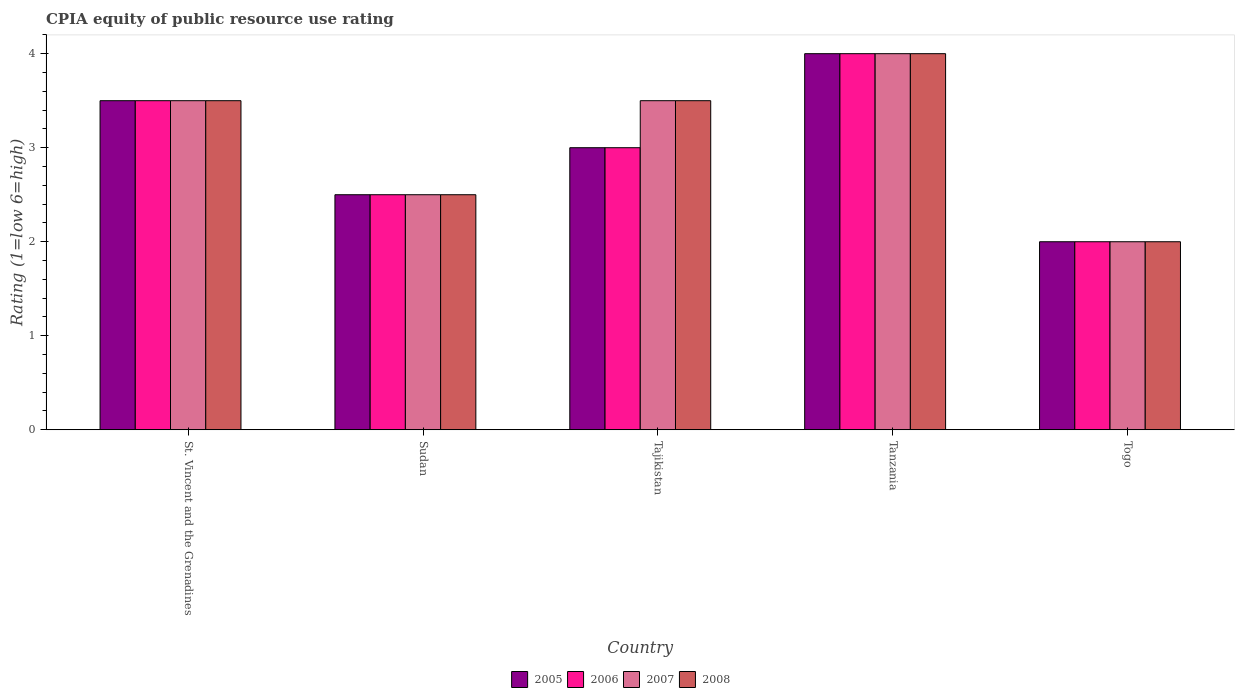Are the number of bars per tick equal to the number of legend labels?
Offer a terse response. Yes. Are the number of bars on each tick of the X-axis equal?
Your answer should be compact. Yes. What is the label of the 3rd group of bars from the left?
Your answer should be very brief. Tajikistan. In how many cases, is the number of bars for a given country not equal to the number of legend labels?
Ensure brevity in your answer.  0. Across all countries, what is the minimum CPIA rating in 2007?
Make the answer very short. 2. In which country was the CPIA rating in 2007 maximum?
Keep it short and to the point. Tanzania. In which country was the CPIA rating in 2007 minimum?
Provide a succinct answer. Togo. What is the difference between the CPIA rating in 2008 in St. Vincent and the Grenadines and that in Togo?
Keep it short and to the point. 1.5. What is the ratio of the CPIA rating in 2006 in Tajikistan to that in Tanzania?
Your answer should be very brief. 0.75. Is the CPIA rating in 2006 in St. Vincent and the Grenadines less than that in Togo?
Offer a very short reply. No. What is the difference between the highest and the lowest CPIA rating in 2006?
Give a very brief answer. 2. Is the sum of the CPIA rating in 2005 in Tanzania and Togo greater than the maximum CPIA rating in 2006 across all countries?
Offer a very short reply. Yes. Is it the case that in every country, the sum of the CPIA rating in 2006 and CPIA rating in 2008 is greater than the sum of CPIA rating in 2007 and CPIA rating in 2005?
Give a very brief answer. No. What does the 4th bar from the right in Tajikistan represents?
Keep it short and to the point. 2005. How many countries are there in the graph?
Your answer should be compact. 5. What is the difference between two consecutive major ticks on the Y-axis?
Your answer should be very brief. 1. Are the values on the major ticks of Y-axis written in scientific E-notation?
Make the answer very short. No. Does the graph contain any zero values?
Your answer should be very brief. No. Does the graph contain grids?
Give a very brief answer. No. Where does the legend appear in the graph?
Offer a very short reply. Bottom center. How are the legend labels stacked?
Offer a very short reply. Horizontal. What is the title of the graph?
Ensure brevity in your answer.  CPIA equity of public resource use rating. What is the Rating (1=low 6=high) of 2006 in St. Vincent and the Grenadines?
Offer a terse response. 3.5. What is the Rating (1=low 6=high) in 2007 in St. Vincent and the Grenadines?
Offer a terse response. 3.5. What is the Rating (1=low 6=high) of 2008 in St. Vincent and the Grenadines?
Keep it short and to the point. 3.5. What is the Rating (1=low 6=high) of 2006 in Sudan?
Make the answer very short. 2.5. What is the Rating (1=low 6=high) of 2007 in Sudan?
Offer a terse response. 2.5. What is the Rating (1=low 6=high) of 2005 in Tajikistan?
Ensure brevity in your answer.  3. What is the Rating (1=low 6=high) in 2007 in Tajikistan?
Make the answer very short. 3.5. What is the Rating (1=low 6=high) of 2005 in Tanzania?
Give a very brief answer. 4. What is the Rating (1=low 6=high) of 2006 in Tanzania?
Your answer should be compact. 4. What is the Rating (1=low 6=high) of 2007 in Togo?
Give a very brief answer. 2. What is the Rating (1=low 6=high) of 2008 in Togo?
Make the answer very short. 2. Across all countries, what is the minimum Rating (1=low 6=high) in 2006?
Give a very brief answer. 2. Across all countries, what is the minimum Rating (1=low 6=high) of 2008?
Give a very brief answer. 2. What is the total Rating (1=low 6=high) of 2005 in the graph?
Your answer should be compact. 15. What is the total Rating (1=low 6=high) in 2006 in the graph?
Your answer should be very brief. 15. What is the total Rating (1=low 6=high) of 2008 in the graph?
Your answer should be compact. 15.5. What is the difference between the Rating (1=low 6=high) of 2005 in St. Vincent and the Grenadines and that in Sudan?
Your response must be concise. 1. What is the difference between the Rating (1=low 6=high) in 2006 in St. Vincent and the Grenadines and that in Sudan?
Provide a succinct answer. 1. What is the difference between the Rating (1=low 6=high) in 2007 in St. Vincent and the Grenadines and that in Sudan?
Make the answer very short. 1. What is the difference between the Rating (1=low 6=high) of 2005 in St. Vincent and the Grenadines and that in Tajikistan?
Make the answer very short. 0.5. What is the difference between the Rating (1=low 6=high) in 2007 in St. Vincent and the Grenadines and that in Tajikistan?
Your answer should be compact. 0. What is the difference between the Rating (1=low 6=high) of 2006 in St. Vincent and the Grenadines and that in Tanzania?
Give a very brief answer. -0.5. What is the difference between the Rating (1=low 6=high) of 2007 in St. Vincent and the Grenadines and that in Tanzania?
Offer a very short reply. -0.5. What is the difference between the Rating (1=low 6=high) of 2006 in St. Vincent and the Grenadines and that in Togo?
Make the answer very short. 1.5. What is the difference between the Rating (1=low 6=high) in 2008 in St. Vincent and the Grenadines and that in Togo?
Keep it short and to the point. 1.5. What is the difference between the Rating (1=low 6=high) in 2005 in Sudan and that in Tajikistan?
Your answer should be very brief. -0.5. What is the difference between the Rating (1=low 6=high) in 2007 in Sudan and that in Tajikistan?
Provide a succinct answer. -1. What is the difference between the Rating (1=low 6=high) of 2008 in Sudan and that in Tajikistan?
Your response must be concise. -1. What is the difference between the Rating (1=low 6=high) of 2005 in Sudan and that in Tanzania?
Offer a very short reply. -1.5. What is the difference between the Rating (1=low 6=high) in 2007 in Sudan and that in Tanzania?
Keep it short and to the point. -1.5. What is the difference between the Rating (1=low 6=high) of 2008 in Sudan and that in Tanzania?
Your answer should be very brief. -1.5. What is the difference between the Rating (1=low 6=high) of 2006 in Sudan and that in Togo?
Provide a short and direct response. 0.5. What is the difference between the Rating (1=low 6=high) of 2007 in Sudan and that in Togo?
Ensure brevity in your answer.  0.5. What is the difference between the Rating (1=low 6=high) in 2006 in Tajikistan and that in Tanzania?
Your answer should be compact. -1. What is the difference between the Rating (1=low 6=high) of 2006 in Tajikistan and that in Togo?
Keep it short and to the point. 1. What is the difference between the Rating (1=low 6=high) of 2007 in Tajikistan and that in Togo?
Keep it short and to the point. 1.5. What is the difference between the Rating (1=low 6=high) in 2008 in Tajikistan and that in Togo?
Keep it short and to the point. 1.5. What is the difference between the Rating (1=low 6=high) in 2007 in Tanzania and that in Togo?
Ensure brevity in your answer.  2. What is the difference between the Rating (1=low 6=high) of 2008 in Tanzania and that in Togo?
Ensure brevity in your answer.  2. What is the difference between the Rating (1=low 6=high) in 2005 in St. Vincent and the Grenadines and the Rating (1=low 6=high) in 2007 in Sudan?
Your answer should be compact. 1. What is the difference between the Rating (1=low 6=high) in 2006 in St. Vincent and the Grenadines and the Rating (1=low 6=high) in 2007 in Sudan?
Offer a terse response. 1. What is the difference between the Rating (1=low 6=high) of 2005 in St. Vincent and the Grenadines and the Rating (1=low 6=high) of 2006 in Tajikistan?
Provide a succinct answer. 0.5. What is the difference between the Rating (1=low 6=high) of 2005 in St. Vincent and the Grenadines and the Rating (1=low 6=high) of 2007 in Tajikistan?
Keep it short and to the point. 0. What is the difference between the Rating (1=low 6=high) in 2005 in St. Vincent and the Grenadines and the Rating (1=low 6=high) in 2008 in Tajikistan?
Your answer should be very brief. 0. What is the difference between the Rating (1=low 6=high) in 2006 in St. Vincent and the Grenadines and the Rating (1=low 6=high) in 2007 in Tajikistan?
Your answer should be very brief. 0. What is the difference between the Rating (1=low 6=high) in 2007 in St. Vincent and the Grenadines and the Rating (1=low 6=high) in 2008 in Tajikistan?
Keep it short and to the point. 0. What is the difference between the Rating (1=low 6=high) of 2005 in St. Vincent and the Grenadines and the Rating (1=low 6=high) of 2008 in Tanzania?
Give a very brief answer. -0.5. What is the difference between the Rating (1=low 6=high) in 2006 in St. Vincent and the Grenadines and the Rating (1=low 6=high) in 2007 in Tanzania?
Give a very brief answer. -0.5. What is the difference between the Rating (1=low 6=high) of 2007 in St. Vincent and the Grenadines and the Rating (1=low 6=high) of 2008 in Tanzania?
Make the answer very short. -0.5. What is the difference between the Rating (1=low 6=high) of 2005 in St. Vincent and the Grenadines and the Rating (1=low 6=high) of 2008 in Togo?
Your response must be concise. 1.5. What is the difference between the Rating (1=low 6=high) of 2007 in St. Vincent and the Grenadines and the Rating (1=low 6=high) of 2008 in Togo?
Your answer should be compact. 1.5. What is the difference between the Rating (1=low 6=high) in 2005 in Sudan and the Rating (1=low 6=high) in 2006 in Tajikistan?
Your answer should be very brief. -0.5. What is the difference between the Rating (1=low 6=high) of 2005 in Sudan and the Rating (1=low 6=high) of 2007 in Tajikistan?
Provide a succinct answer. -1. What is the difference between the Rating (1=low 6=high) in 2005 in Sudan and the Rating (1=low 6=high) in 2008 in Tajikistan?
Offer a terse response. -1. What is the difference between the Rating (1=low 6=high) in 2006 in Sudan and the Rating (1=low 6=high) in 2007 in Tajikistan?
Provide a short and direct response. -1. What is the difference between the Rating (1=low 6=high) of 2006 in Sudan and the Rating (1=low 6=high) of 2008 in Tajikistan?
Your response must be concise. -1. What is the difference between the Rating (1=low 6=high) in 2005 in Sudan and the Rating (1=low 6=high) in 2006 in Tanzania?
Provide a succinct answer. -1.5. What is the difference between the Rating (1=low 6=high) of 2006 in Sudan and the Rating (1=low 6=high) of 2008 in Tanzania?
Offer a very short reply. -1.5. What is the difference between the Rating (1=low 6=high) in 2005 in Sudan and the Rating (1=low 6=high) in 2006 in Togo?
Make the answer very short. 0.5. What is the difference between the Rating (1=low 6=high) in 2005 in Sudan and the Rating (1=low 6=high) in 2007 in Togo?
Your answer should be compact. 0.5. What is the difference between the Rating (1=low 6=high) of 2006 in Sudan and the Rating (1=low 6=high) of 2007 in Togo?
Ensure brevity in your answer.  0.5. What is the difference between the Rating (1=low 6=high) of 2006 in Sudan and the Rating (1=low 6=high) of 2008 in Togo?
Make the answer very short. 0.5. What is the difference between the Rating (1=low 6=high) of 2007 in Sudan and the Rating (1=low 6=high) of 2008 in Togo?
Offer a terse response. 0.5. What is the difference between the Rating (1=low 6=high) of 2007 in Tajikistan and the Rating (1=low 6=high) of 2008 in Tanzania?
Provide a succinct answer. -0.5. What is the difference between the Rating (1=low 6=high) in 2005 in Tajikistan and the Rating (1=low 6=high) in 2008 in Togo?
Give a very brief answer. 1. What is the difference between the Rating (1=low 6=high) of 2006 in Tajikistan and the Rating (1=low 6=high) of 2007 in Togo?
Give a very brief answer. 1. What is the difference between the Rating (1=low 6=high) of 2006 in Tajikistan and the Rating (1=low 6=high) of 2008 in Togo?
Your answer should be very brief. 1. What is the difference between the Rating (1=low 6=high) in 2007 in Tajikistan and the Rating (1=low 6=high) in 2008 in Togo?
Your answer should be compact. 1.5. What is the difference between the Rating (1=low 6=high) of 2007 in Tanzania and the Rating (1=low 6=high) of 2008 in Togo?
Your response must be concise. 2. What is the average Rating (1=low 6=high) of 2006 per country?
Keep it short and to the point. 3. What is the average Rating (1=low 6=high) of 2008 per country?
Keep it short and to the point. 3.1. What is the difference between the Rating (1=low 6=high) of 2007 and Rating (1=low 6=high) of 2008 in St. Vincent and the Grenadines?
Ensure brevity in your answer.  0. What is the difference between the Rating (1=low 6=high) of 2005 and Rating (1=low 6=high) of 2006 in Sudan?
Provide a short and direct response. 0. What is the difference between the Rating (1=low 6=high) in 2005 and Rating (1=low 6=high) in 2007 in Sudan?
Provide a short and direct response. 0. What is the difference between the Rating (1=low 6=high) in 2005 and Rating (1=low 6=high) in 2008 in Sudan?
Ensure brevity in your answer.  0. What is the difference between the Rating (1=low 6=high) of 2006 and Rating (1=low 6=high) of 2007 in Sudan?
Ensure brevity in your answer.  0. What is the difference between the Rating (1=low 6=high) in 2007 and Rating (1=low 6=high) in 2008 in Sudan?
Provide a short and direct response. 0. What is the difference between the Rating (1=low 6=high) of 2005 and Rating (1=low 6=high) of 2006 in Tajikistan?
Ensure brevity in your answer.  0. What is the difference between the Rating (1=low 6=high) in 2005 and Rating (1=low 6=high) in 2008 in Tajikistan?
Your answer should be compact. -0.5. What is the difference between the Rating (1=low 6=high) of 2006 and Rating (1=low 6=high) of 2008 in Tajikistan?
Your answer should be very brief. -0.5. What is the difference between the Rating (1=low 6=high) of 2007 and Rating (1=low 6=high) of 2008 in Tajikistan?
Offer a very short reply. 0. What is the difference between the Rating (1=low 6=high) in 2005 and Rating (1=low 6=high) in 2006 in Tanzania?
Provide a succinct answer. 0. What is the difference between the Rating (1=low 6=high) of 2006 and Rating (1=low 6=high) of 2008 in Tanzania?
Your response must be concise. 0. What is the difference between the Rating (1=low 6=high) of 2005 and Rating (1=low 6=high) of 2006 in Togo?
Make the answer very short. 0. What is the difference between the Rating (1=low 6=high) of 2005 and Rating (1=low 6=high) of 2007 in Togo?
Offer a terse response. 0. What is the difference between the Rating (1=low 6=high) in 2005 and Rating (1=low 6=high) in 2008 in Togo?
Make the answer very short. 0. What is the difference between the Rating (1=low 6=high) in 2006 and Rating (1=low 6=high) in 2007 in Togo?
Provide a succinct answer. 0. What is the difference between the Rating (1=low 6=high) of 2007 and Rating (1=low 6=high) of 2008 in Togo?
Keep it short and to the point. 0. What is the ratio of the Rating (1=low 6=high) in 2007 in St. Vincent and the Grenadines to that in Sudan?
Your answer should be very brief. 1.4. What is the ratio of the Rating (1=low 6=high) in 2005 in St. Vincent and the Grenadines to that in Tajikistan?
Provide a short and direct response. 1.17. What is the ratio of the Rating (1=low 6=high) in 2006 in St. Vincent and the Grenadines to that in Tanzania?
Offer a terse response. 0.88. What is the ratio of the Rating (1=low 6=high) of 2007 in St. Vincent and the Grenadines to that in Tanzania?
Your response must be concise. 0.88. What is the ratio of the Rating (1=low 6=high) in 2006 in St. Vincent and the Grenadines to that in Togo?
Make the answer very short. 1.75. What is the ratio of the Rating (1=low 6=high) in 2007 in St. Vincent and the Grenadines to that in Togo?
Keep it short and to the point. 1.75. What is the ratio of the Rating (1=low 6=high) of 2006 in Sudan to that in Tajikistan?
Make the answer very short. 0.83. What is the ratio of the Rating (1=low 6=high) in 2007 in Sudan to that in Tajikistan?
Your answer should be very brief. 0.71. What is the ratio of the Rating (1=low 6=high) in 2008 in Sudan to that in Tajikistan?
Provide a succinct answer. 0.71. What is the ratio of the Rating (1=low 6=high) of 2005 in Sudan to that in Tanzania?
Keep it short and to the point. 0.62. What is the ratio of the Rating (1=low 6=high) of 2008 in Sudan to that in Tanzania?
Provide a short and direct response. 0.62. What is the ratio of the Rating (1=low 6=high) in 2005 in Sudan to that in Togo?
Make the answer very short. 1.25. What is the ratio of the Rating (1=low 6=high) in 2007 in Sudan to that in Togo?
Offer a terse response. 1.25. What is the ratio of the Rating (1=low 6=high) in 2005 in Tajikistan to that in Tanzania?
Provide a succinct answer. 0.75. What is the ratio of the Rating (1=low 6=high) of 2007 in Tajikistan to that in Tanzania?
Make the answer very short. 0.88. What is the ratio of the Rating (1=low 6=high) in 2008 in Tajikistan to that in Tanzania?
Provide a short and direct response. 0.88. What is the ratio of the Rating (1=low 6=high) in 2005 in Tajikistan to that in Togo?
Provide a succinct answer. 1.5. What is the ratio of the Rating (1=low 6=high) of 2006 in Tajikistan to that in Togo?
Give a very brief answer. 1.5. What is the ratio of the Rating (1=low 6=high) in 2008 in Tajikistan to that in Togo?
Your response must be concise. 1.75. What is the ratio of the Rating (1=low 6=high) in 2006 in Tanzania to that in Togo?
Offer a very short reply. 2. What is the ratio of the Rating (1=low 6=high) in 2008 in Tanzania to that in Togo?
Your response must be concise. 2. What is the difference between the highest and the second highest Rating (1=low 6=high) in 2005?
Provide a succinct answer. 0.5. What is the difference between the highest and the second highest Rating (1=low 6=high) of 2006?
Provide a succinct answer. 0.5. What is the difference between the highest and the second highest Rating (1=low 6=high) of 2007?
Make the answer very short. 0.5. What is the difference between the highest and the second highest Rating (1=low 6=high) of 2008?
Give a very brief answer. 0.5. What is the difference between the highest and the lowest Rating (1=low 6=high) in 2006?
Offer a terse response. 2. What is the difference between the highest and the lowest Rating (1=low 6=high) in 2007?
Your response must be concise. 2. What is the difference between the highest and the lowest Rating (1=low 6=high) in 2008?
Your answer should be compact. 2. 